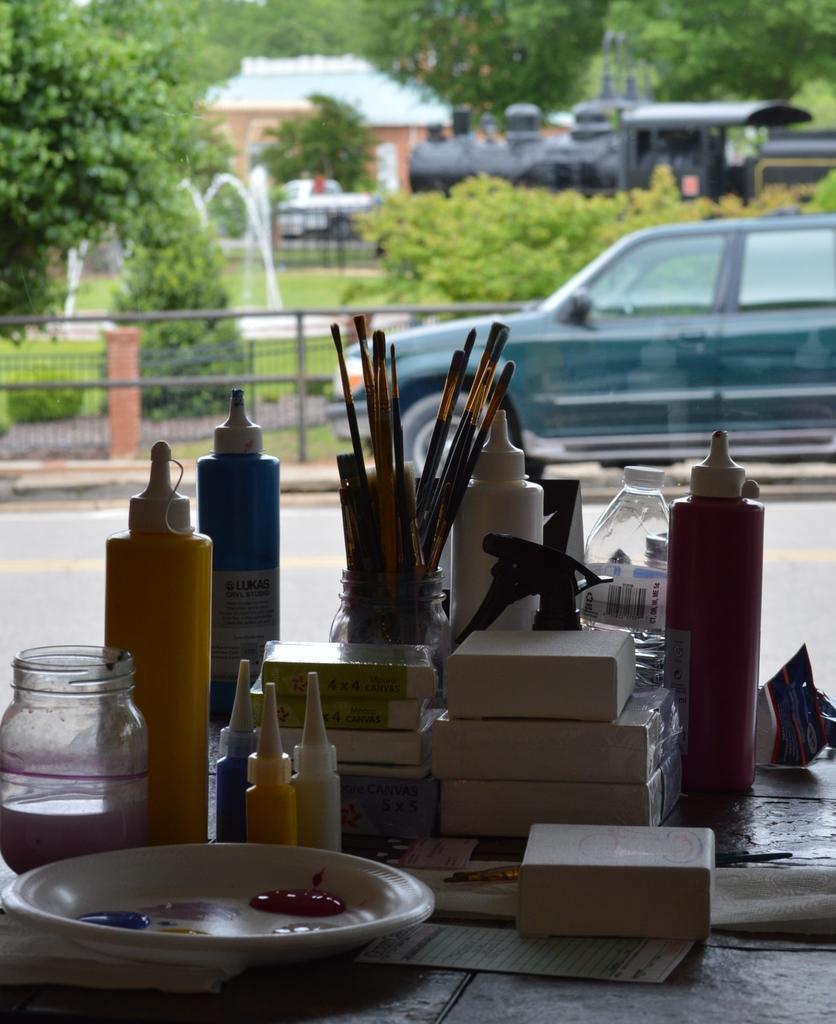Can you describe this image briefly? There is a table which has some objects on it and there is a car and trees in the background. 